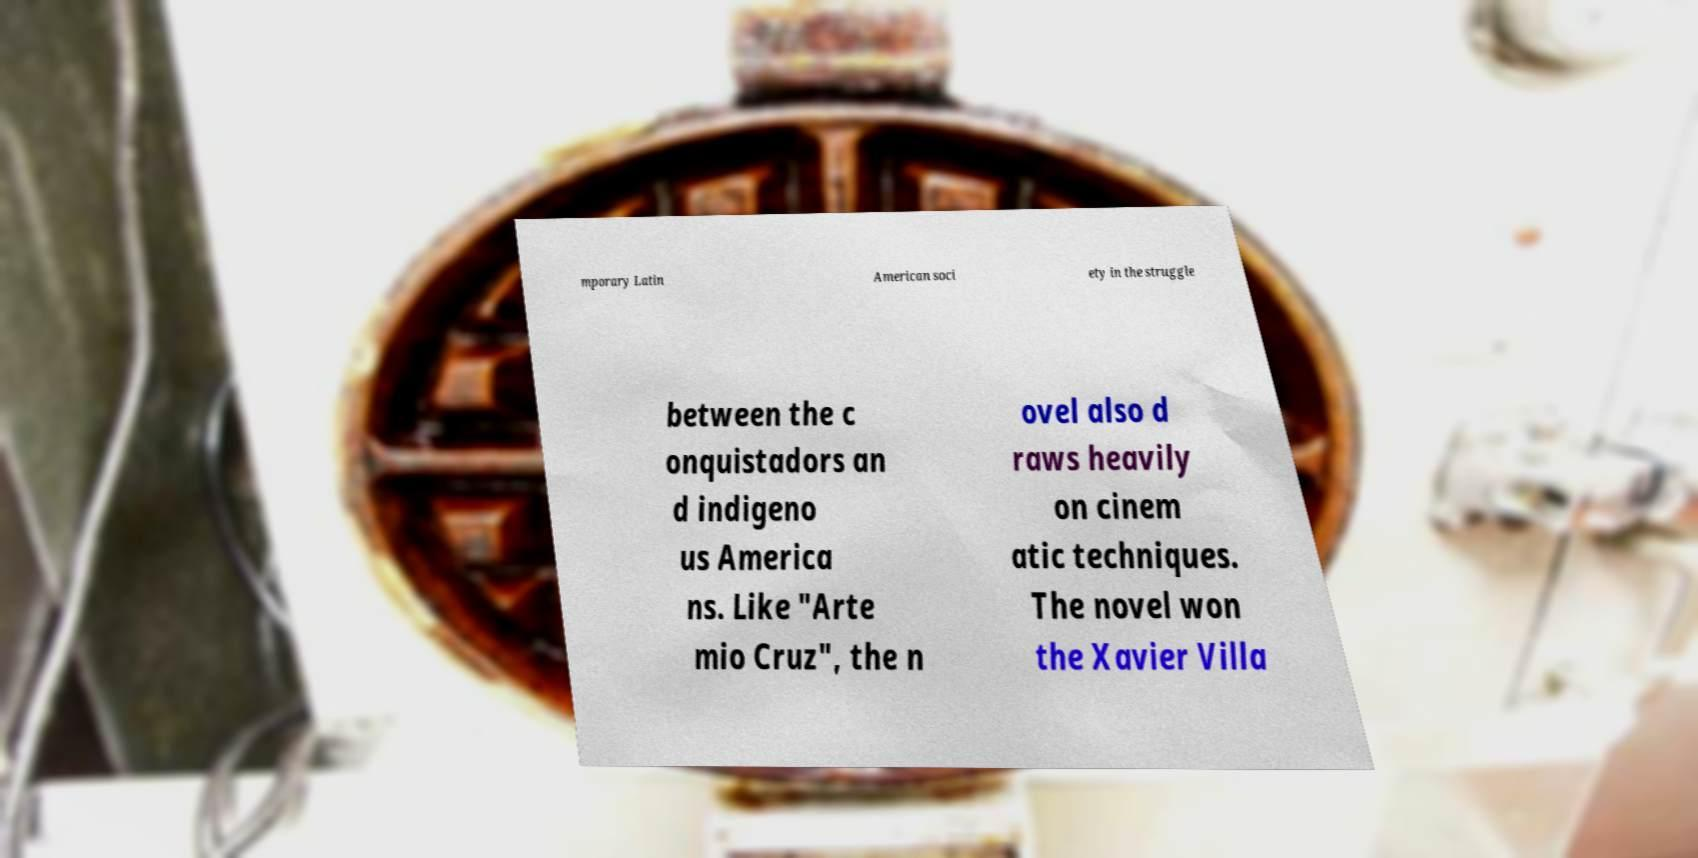Please identify and transcribe the text found in this image. mporary Latin American soci ety in the struggle between the c onquistadors an d indigeno us America ns. Like "Arte mio Cruz", the n ovel also d raws heavily on cinem atic techniques. The novel won the Xavier Villa 